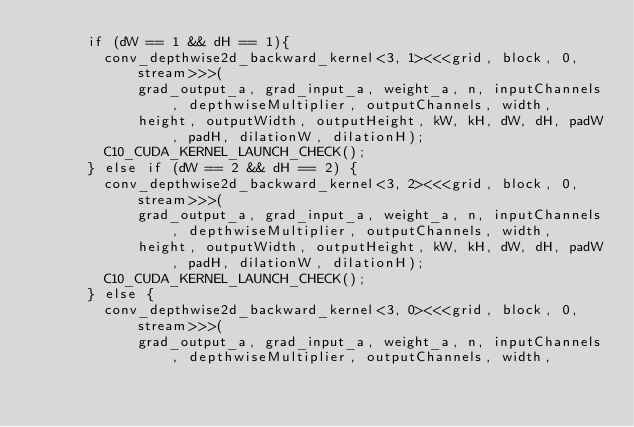<code> <loc_0><loc_0><loc_500><loc_500><_Cuda_>      if (dW == 1 && dH == 1){
        conv_depthwise2d_backward_kernel<3, 1><<<grid, block, 0, stream>>>(
            grad_output_a, grad_input_a, weight_a, n, inputChannels, depthwiseMultiplier, outputChannels, width,
            height, outputWidth, outputHeight, kW, kH, dW, dH, padW, padH, dilationW, dilationH);
        C10_CUDA_KERNEL_LAUNCH_CHECK();
      } else if (dW == 2 && dH == 2) {
        conv_depthwise2d_backward_kernel<3, 2><<<grid, block, 0, stream>>>(
            grad_output_a, grad_input_a, weight_a, n, inputChannels, depthwiseMultiplier, outputChannels, width,
            height, outputWidth, outputHeight, kW, kH, dW, dH, padW, padH, dilationW, dilationH);
        C10_CUDA_KERNEL_LAUNCH_CHECK();
      } else {
        conv_depthwise2d_backward_kernel<3, 0><<<grid, block, 0, stream>>>(
            grad_output_a, grad_input_a, weight_a, n, inputChannels, depthwiseMultiplier, outputChannels, width,</code> 